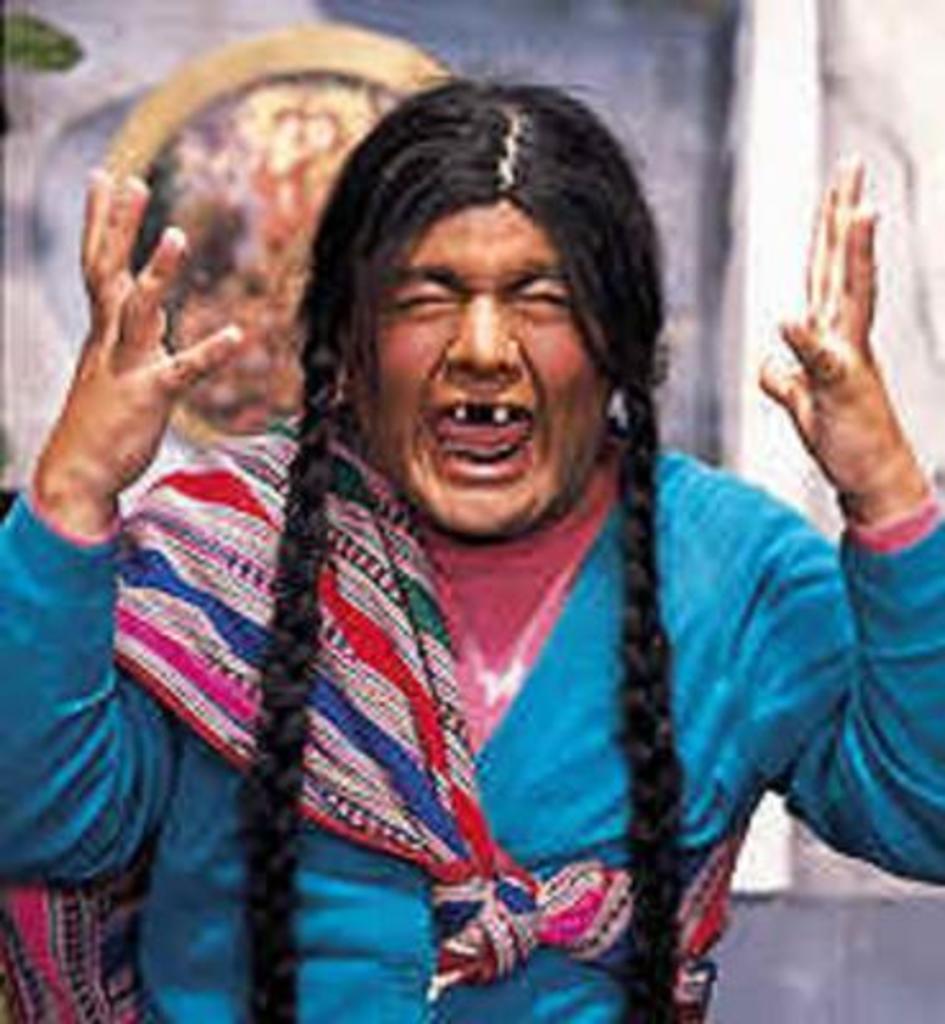How would you summarize this image in a sentence or two? In this image I can see the person is wearing blue and pink color dress. Background is blurred. 